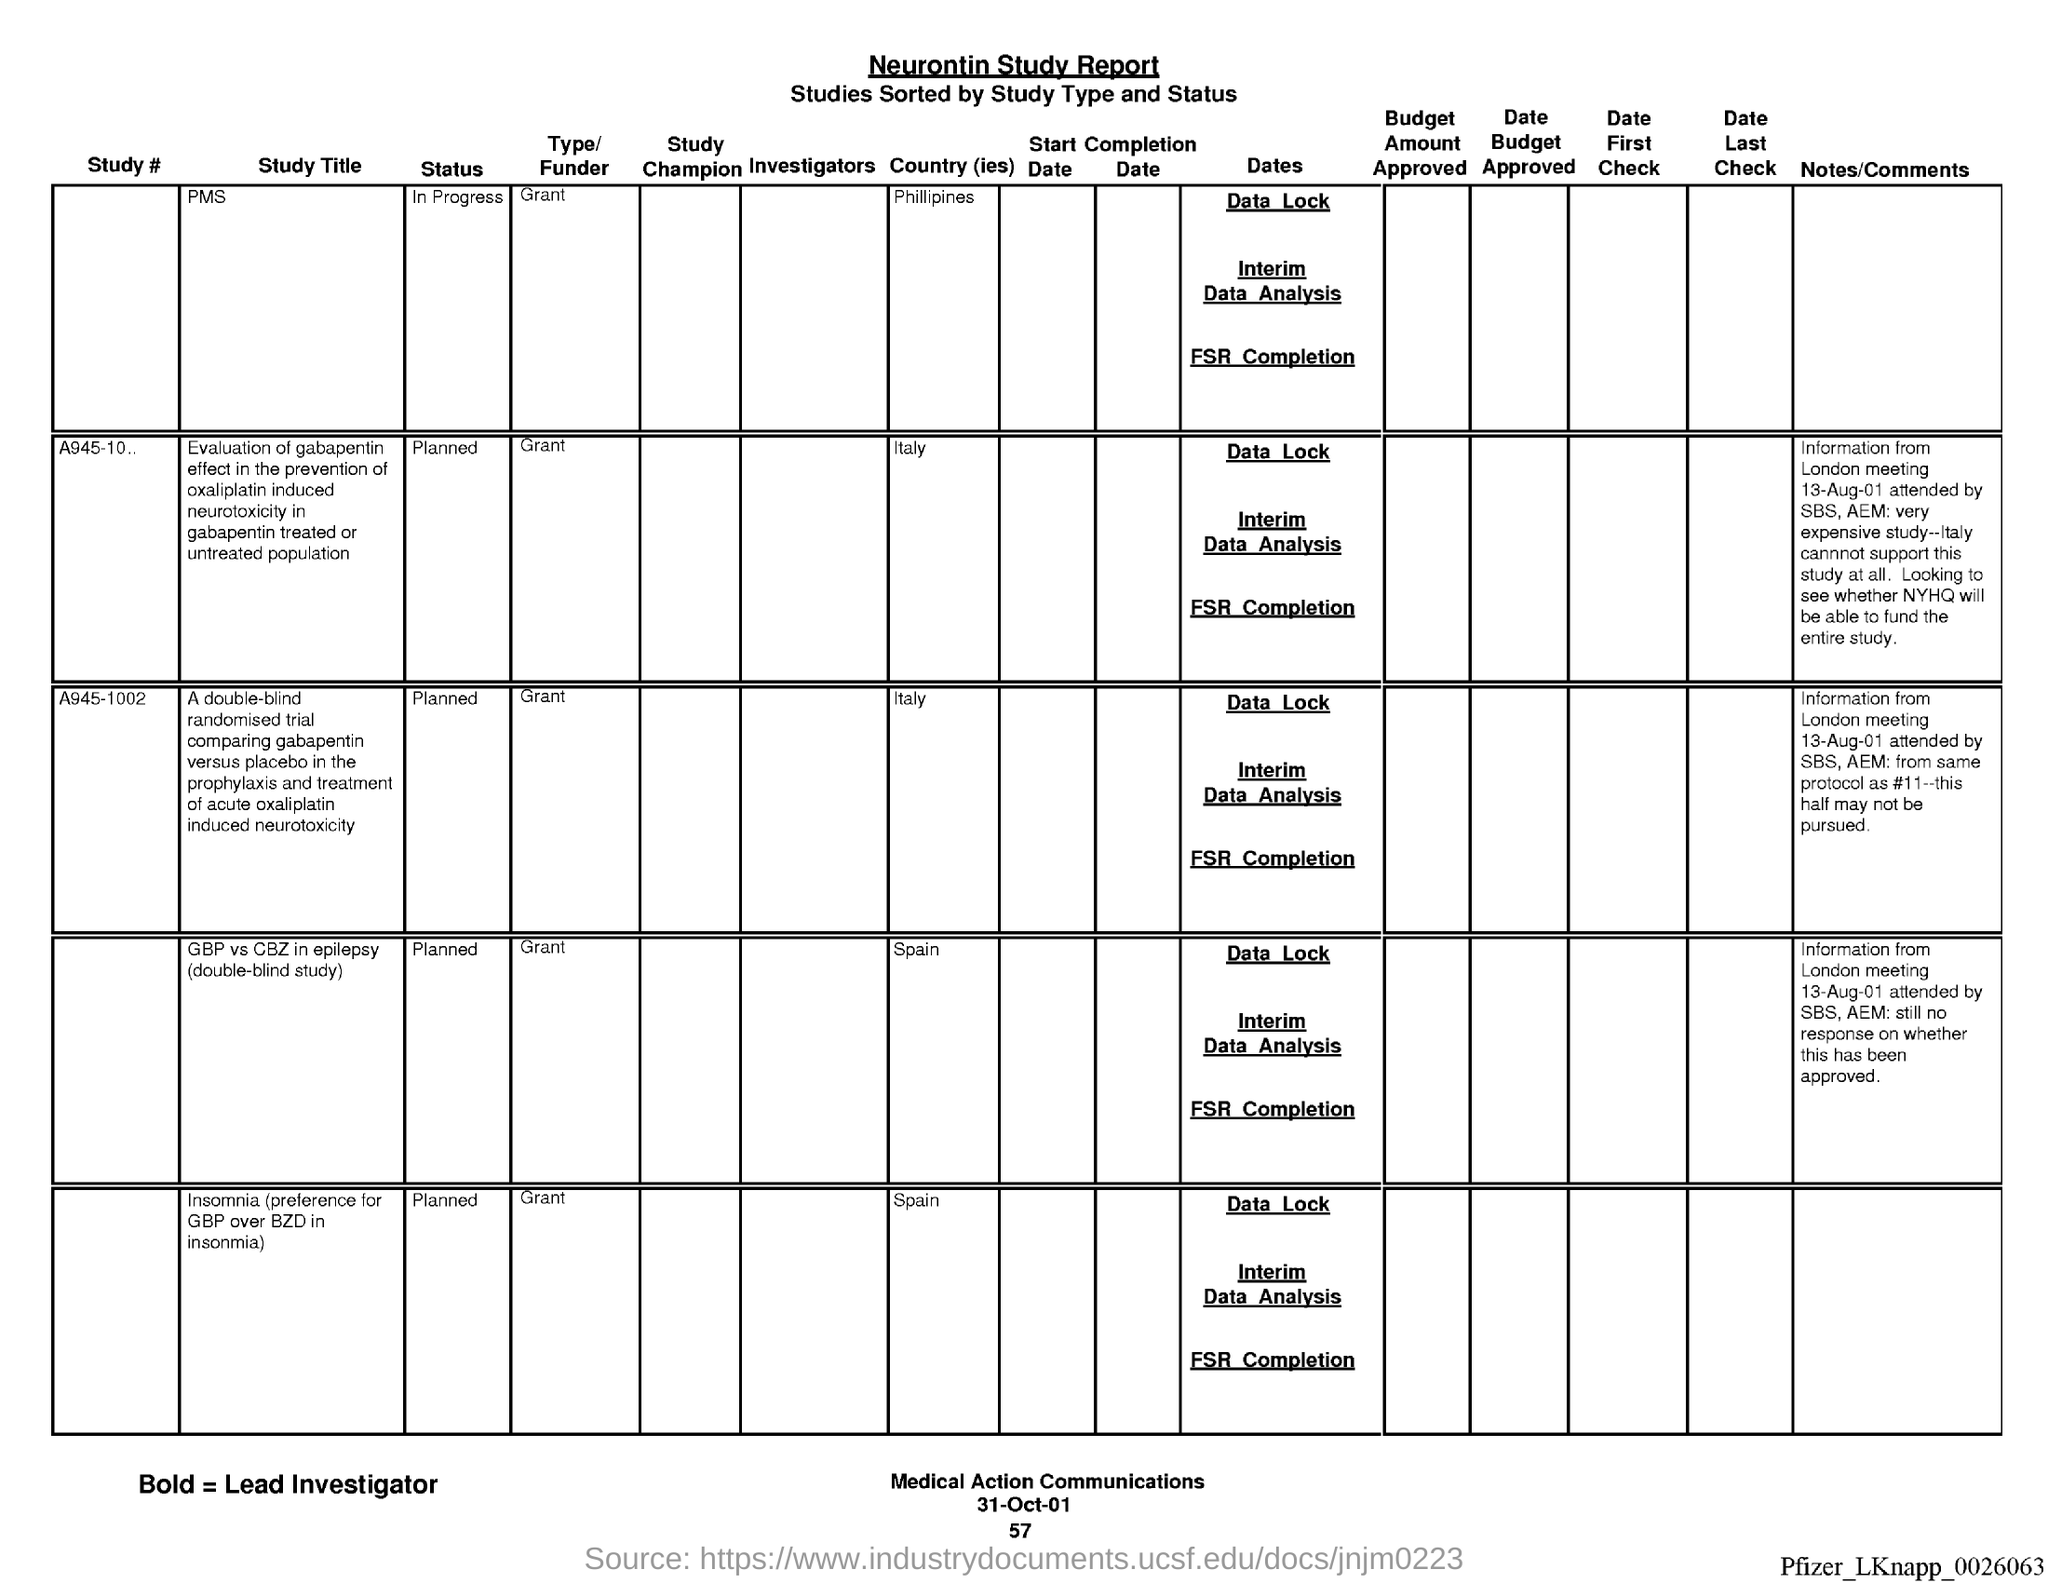What is the name of the report ?
Provide a short and direct response. Neurontin Study report. What is the date at bottom of the page?
Your response must be concise. 31-Oct-01. What is the page number below date?
Keep it short and to the point. 57. 